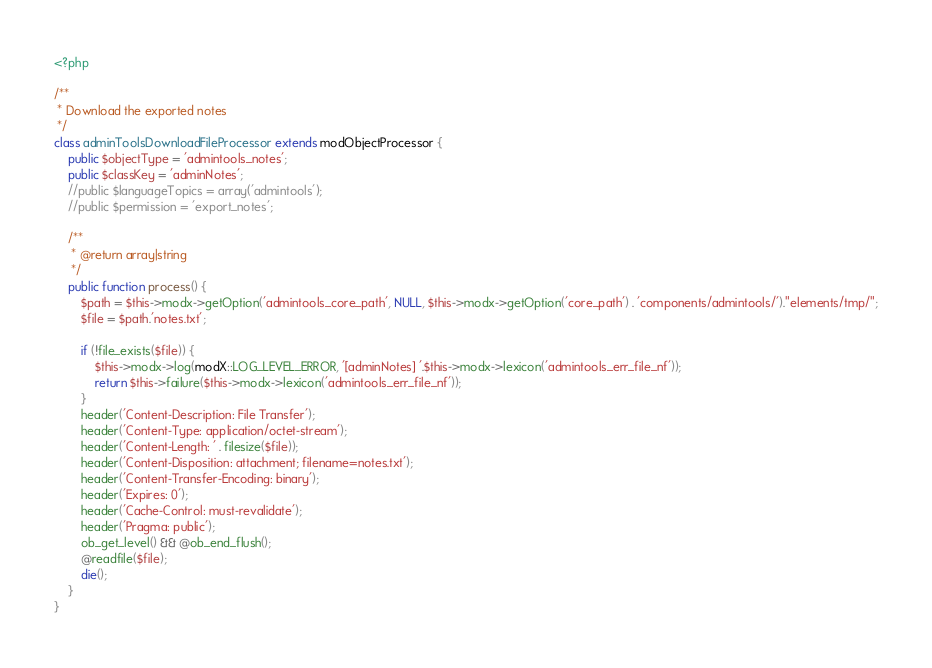<code> <loc_0><loc_0><loc_500><loc_500><_PHP_><?php

/**
 * Download the exported notes
 */
class adminToolsDownloadFileProcessor extends modObjectProcessor {
    public $objectType = 'admintools_notes';
    public $classKey = 'adminNotes';
    //public $languageTopics = array('admintools');
    //public $permission = 'export_notes';

    /**
     * @return array|string
     */
    public function process() {
        $path = $this->modx->getOption('admintools_core_path', NULL, $this->modx->getOption('core_path') . 'components/admintools/')."elements/tmp/";
        $file = $path.'notes.txt';

        if (!file_exists($file)) {
            $this->modx->log(modX::LOG_LEVEL_ERROR, '[adminNotes] '.$this->modx->lexicon('admintools_err_file_nf'));
            return $this->failure($this->modx->lexicon('admintools_err_file_nf'));
        }
        header('Content-Description: File Transfer');
        header('Content-Type: application/octet-stream');
        header('Content-Length: ' . filesize($file));
        header('Content-Disposition: attachment; filename=notes.txt');
        header('Content-Transfer-Encoding: binary');
        header('Expires: 0');
        header('Cache-Control: must-revalidate');
        header('Pragma: public');
        ob_get_level() && @ob_end_flush();
        @readfile($file);
        die();
    }
}
</code> 